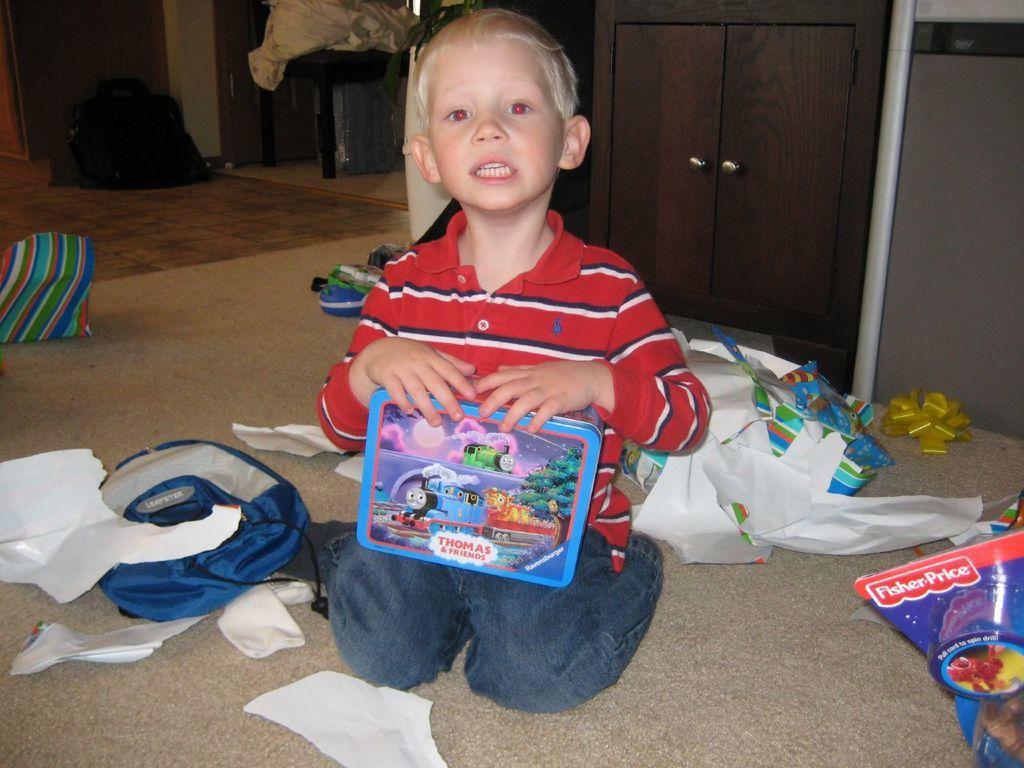How would you summarize this image in a sentence or two? There is a kid sitting and holding box and we can see papers,bags and some objects on floor. Background we can see cupboard and wall. 